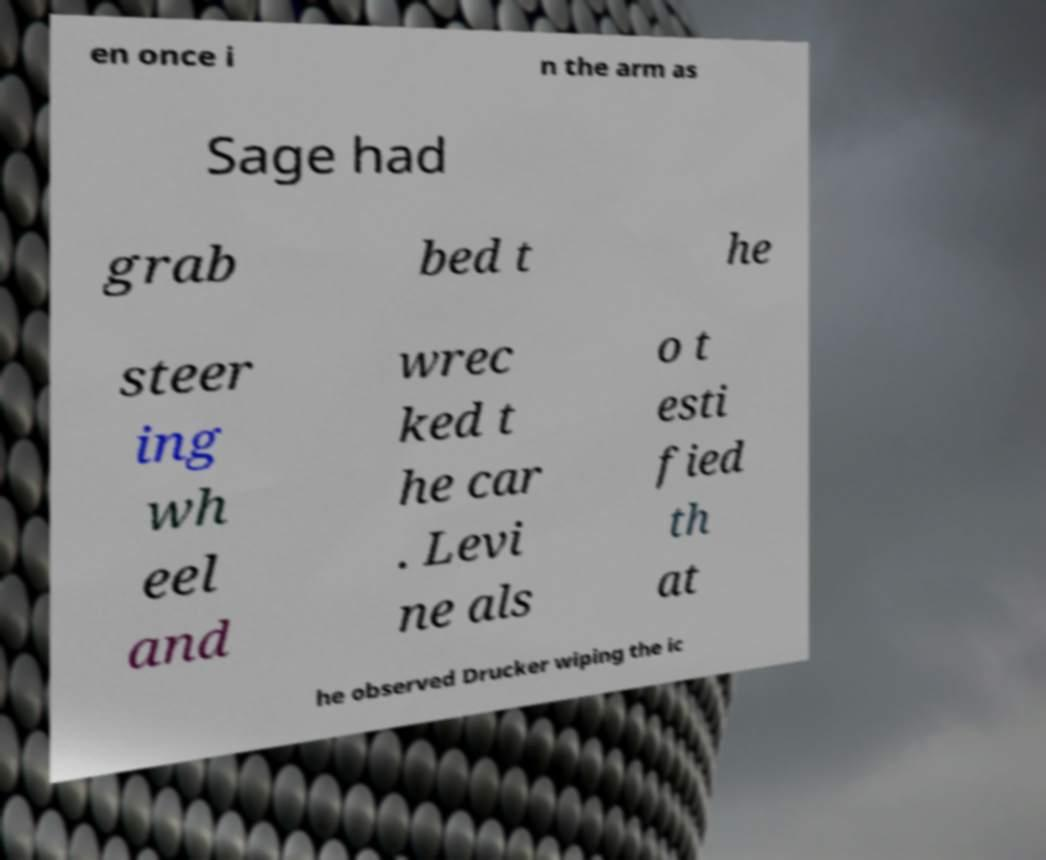There's text embedded in this image that I need extracted. Can you transcribe it verbatim? en once i n the arm as Sage had grab bed t he steer ing wh eel and wrec ked t he car . Levi ne als o t esti fied th at he observed Drucker wiping the ic 